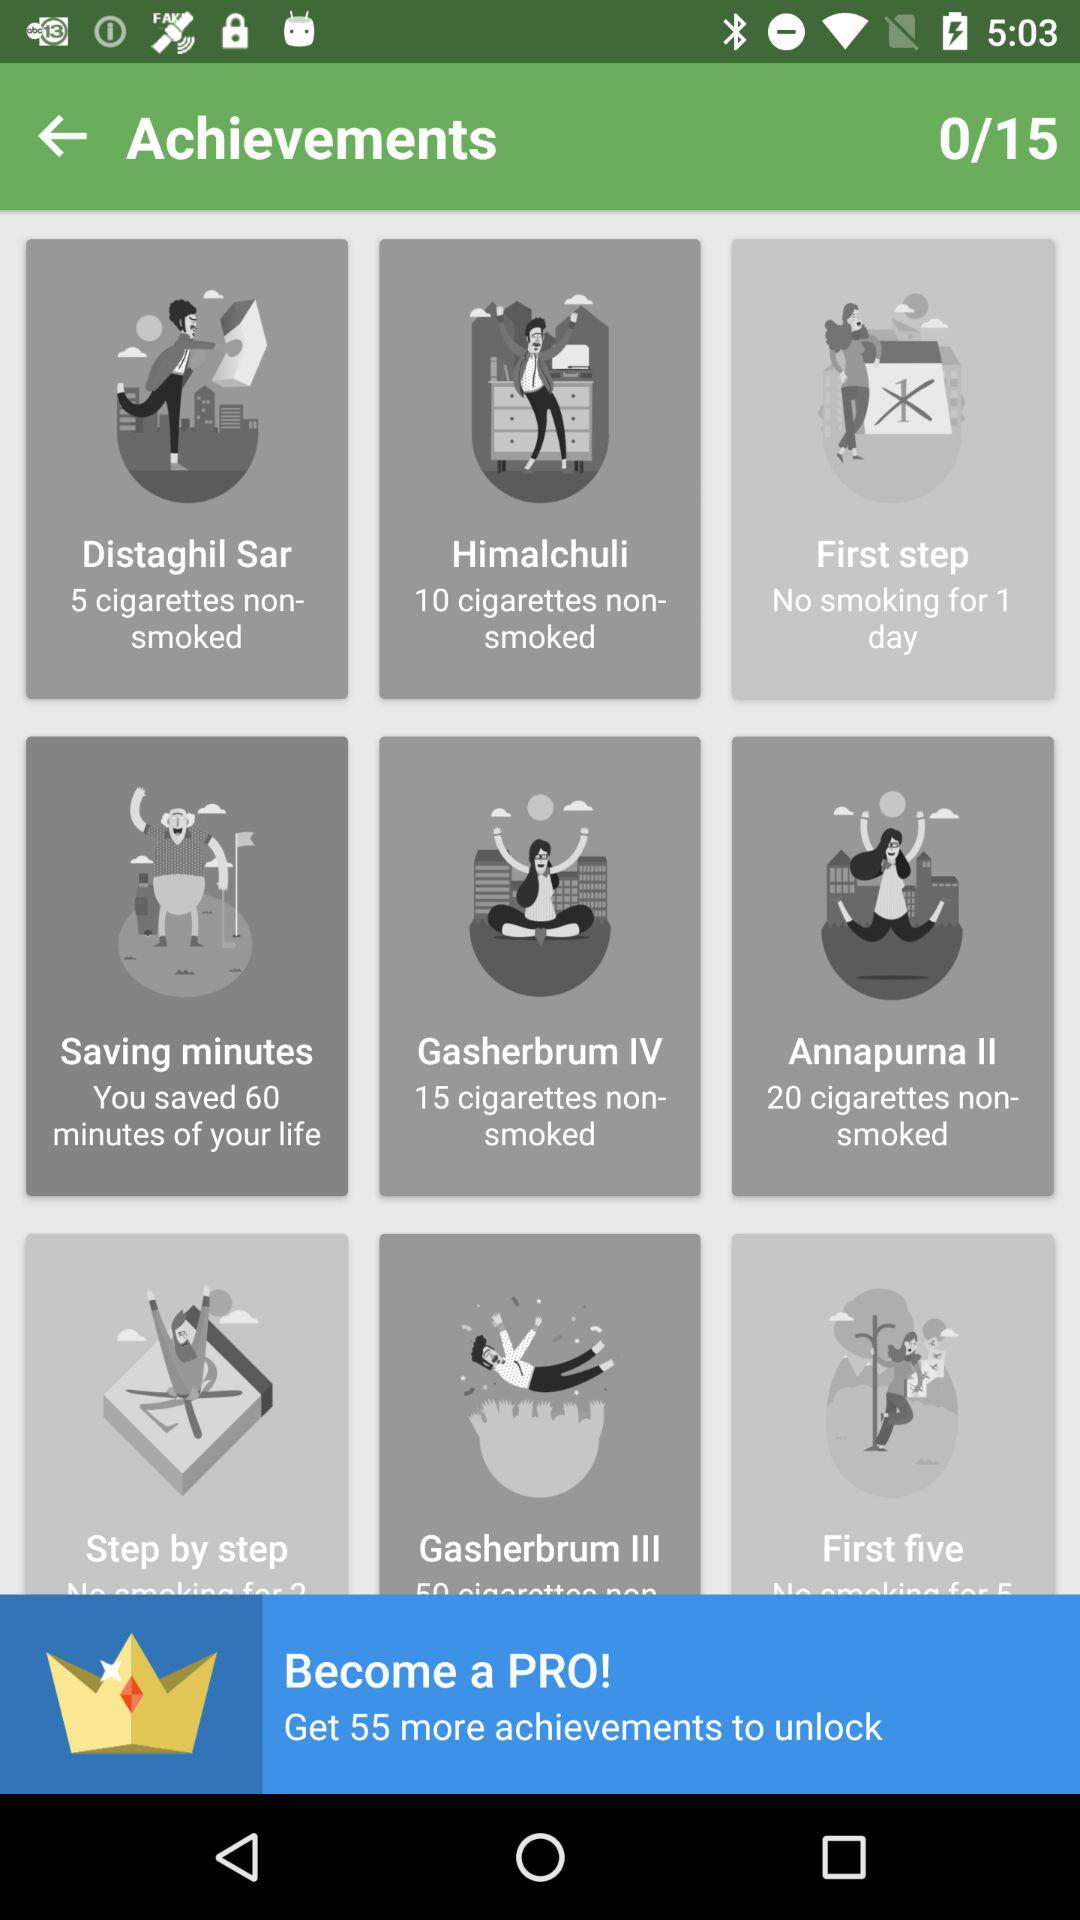How many achievements can I unlock after becoming a pro member? You can unlock 55 more achievements. 